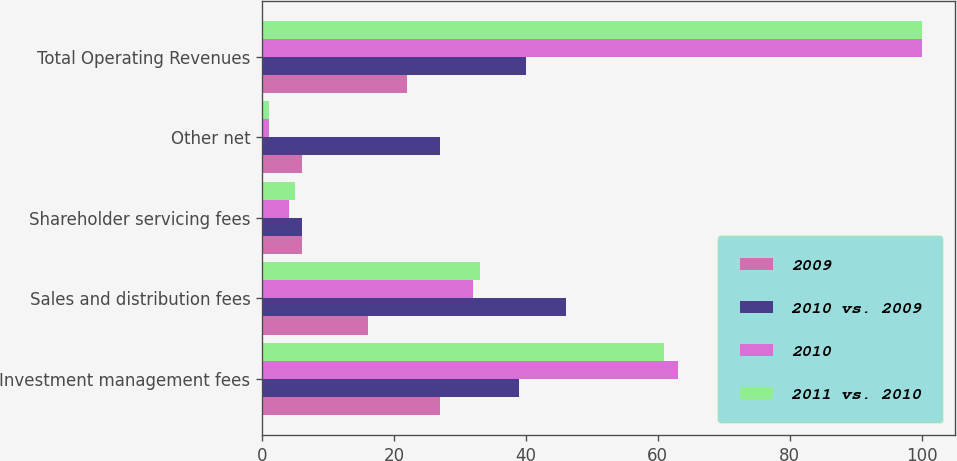Convert chart to OTSL. <chart><loc_0><loc_0><loc_500><loc_500><stacked_bar_chart><ecel><fcel>Investment management fees<fcel>Sales and distribution fees<fcel>Shareholder servicing fees<fcel>Other net<fcel>Total Operating Revenues<nl><fcel>2009<fcel>27<fcel>16<fcel>6<fcel>6<fcel>22<nl><fcel>2010 vs. 2009<fcel>39<fcel>46<fcel>6<fcel>27<fcel>40<nl><fcel>2010<fcel>63<fcel>32<fcel>4<fcel>1<fcel>100<nl><fcel>2011 vs. 2010<fcel>61<fcel>33<fcel>5<fcel>1<fcel>100<nl></chart> 